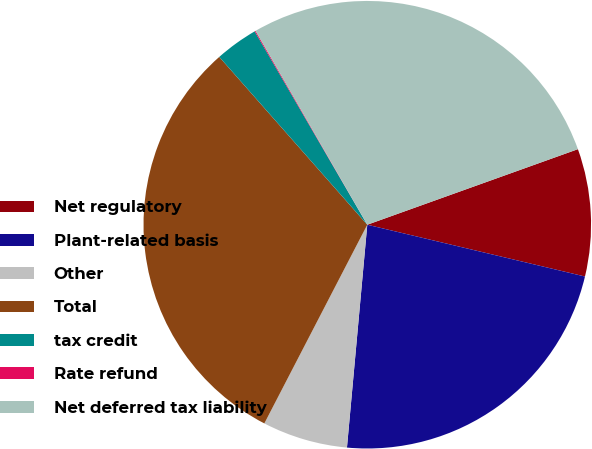<chart> <loc_0><loc_0><loc_500><loc_500><pie_chart><fcel>Net regulatory<fcel>Plant-related basis<fcel>Other<fcel>Total<fcel>tax credit<fcel>Rate refund<fcel>Net deferred tax liability<nl><fcel>9.2%<fcel>22.73%<fcel>6.16%<fcel>30.89%<fcel>3.11%<fcel>0.07%<fcel>27.84%<nl></chart> 